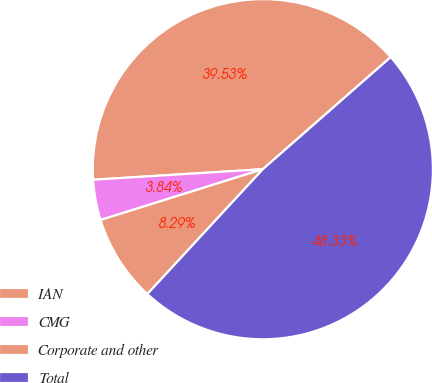Convert chart to OTSL. <chart><loc_0><loc_0><loc_500><loc_500><pie_chart><fcel>IAN<fcel>CMG<fcel>Corporate and other<fcel>Total<nl><fcel>39.53%<fcel>3.84%<fcel>8.29%<fcel>48.33%<nl></chart> 